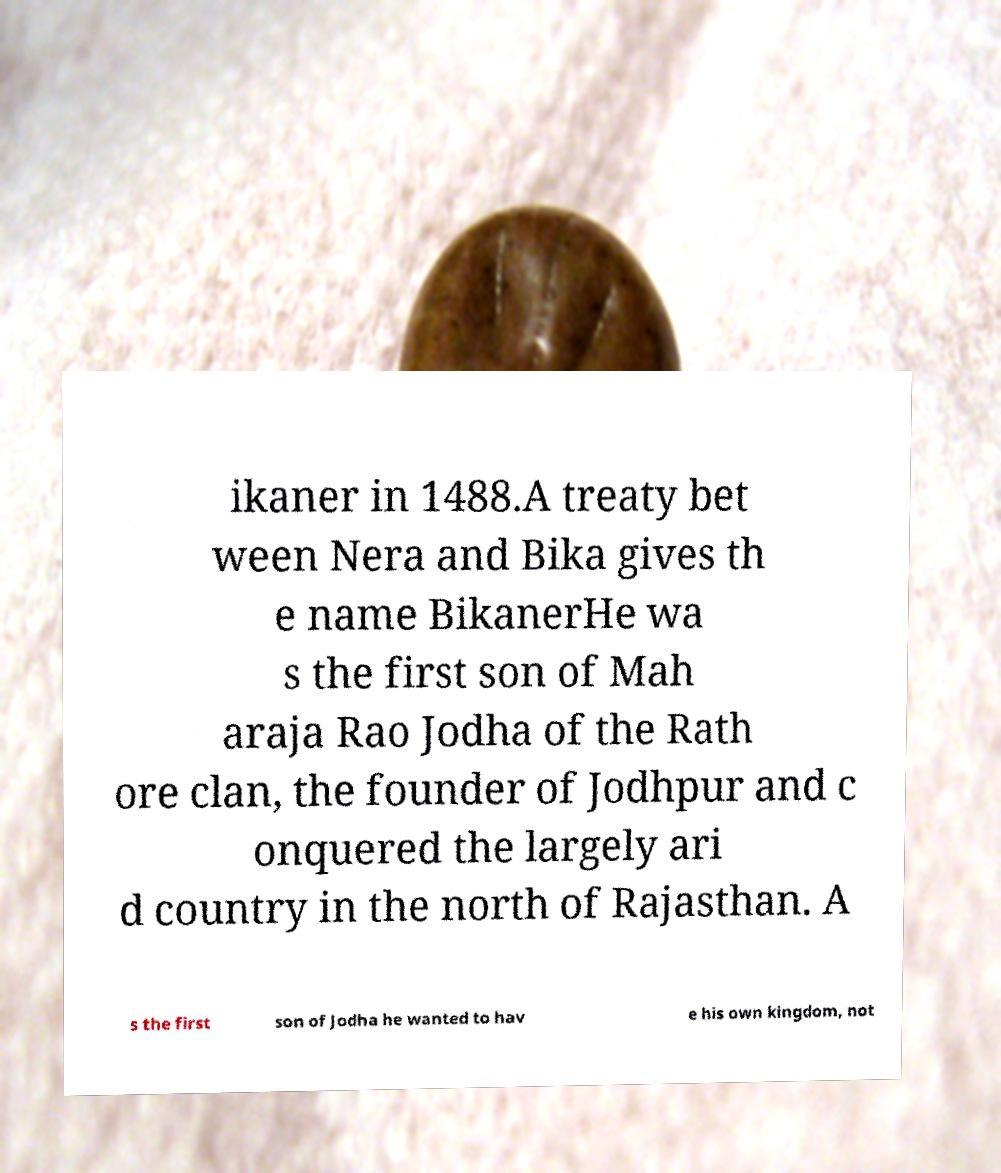Can you read and provide the text displayed in the image?This photo seems to have some interesting text. Can you extract and type it out for me? ikaner in 1488.A treaty bet ween Nera and Bika gives th e name BikanerHe wa s the first son of Mah araja Rao Jodha of the Rath ore clan, the founder of Jodhpur and c onquered the largely ari d country in the north of Rajasthan. A s the first son of Jodha he wanted to hav e his own kingdom, not 